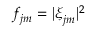Convert formula to latex. <formula><loc_0><loc_0><loc_500><loc_500>f _ { j m } = | \xi _ { j m } | ^ { 2 }</formula> 